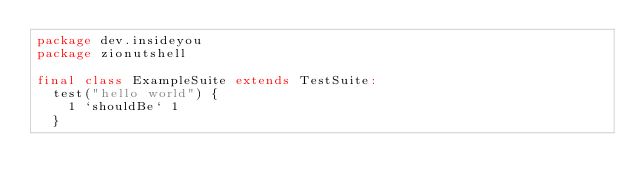Convert code to text. <code><loc_0><loc_0><loc_500><loc_500><_Scala_>package dev.insideyou
package zionutshell

final class ExampleSuite extends TestSuite:
  test("hello world") {
    1 `shouldBe` 1
  }
</code> 